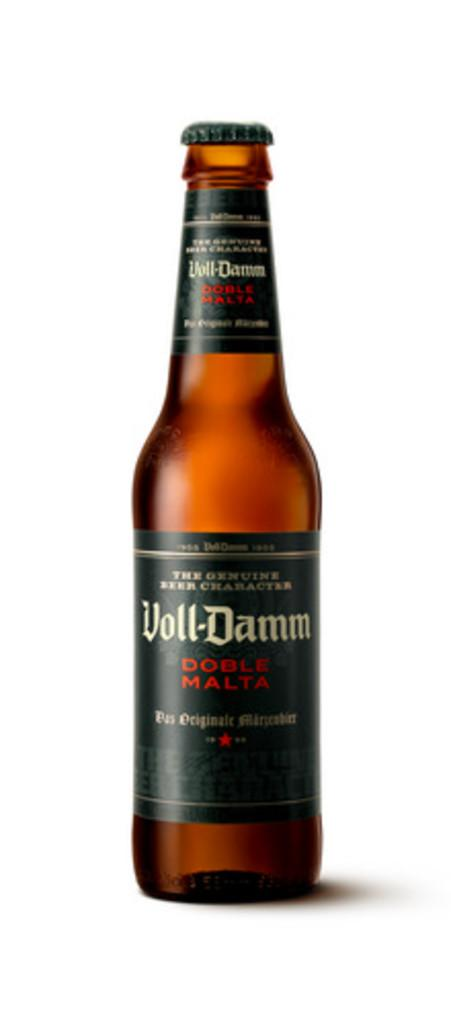<image>
Relay a brief, clear account of the picture shown. a bottle of Voll-Damm liquor to open. 